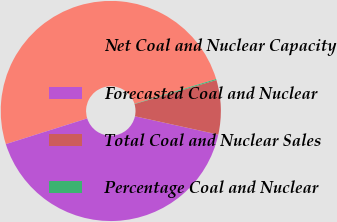<chart> <loc_0><loc_0><loc_500><loc_500><pie_chart><fcel>Net Coal and Nuclear Capacity<fcel>Forecasted Coal and Nuclear<fcel>Total Coal and Nuclear Sales<fcel>Percentage Coal and Nuclear<nl><fcel>50.18%<fcel>41.69%<fcel>7.98%<fcel>0.15%<nl></chart> 